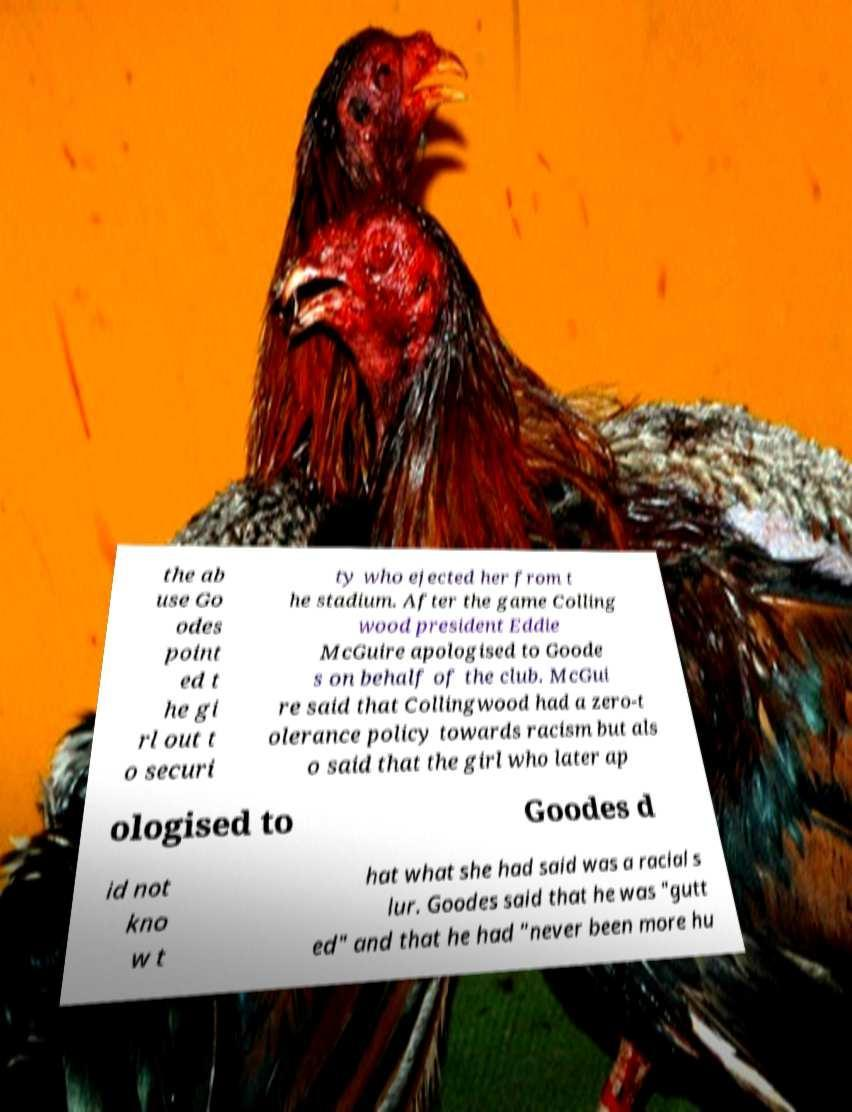For documentation purposes, I need the text within this image transcribed. Could you provide that? the ab use Go odes point ed t he gi rl out t o securi ty who ejected her from t he stadium. After the game Colling wood president Eddie McGuire apologised to Goode s on behalf of the club. McGui re said that Collingwood had a zero-t olerance policy towards racism but als o said that the girl who later ap ologised to Goodes d id not kno w t hat what she had said was a racial s lur. Goodes said that he was "gutt ed" and that he had "never been more hu 